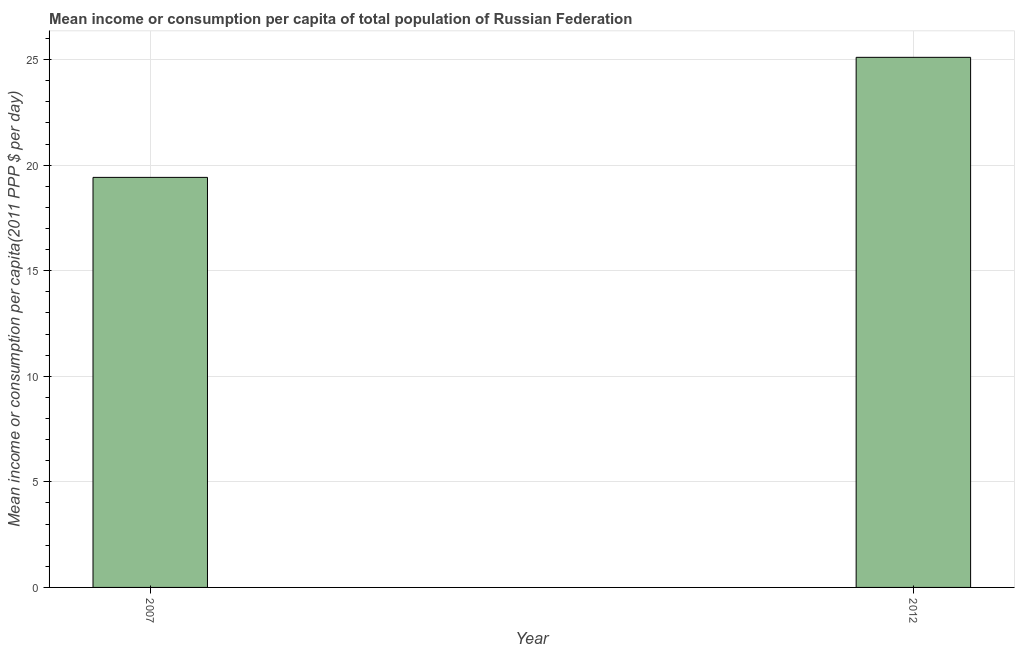What is the title of the graph?
Give a very brief answer. Mean income or consumption per capita of total population of Russian Federation. What is the label or title of the X-axis?
Offer a very short reply. Year. What is the label or title of the Y-axis?
Make the answer very short. Mean income or consumption per capita(2011 PPP $ per day). What is the mean income or consumption in 2007?
Provide a short and direct response. 19.42. Across all years, what is the maximum mean income or consumption?
Give a very brief answer. 25.11. Across all years, what is the minimum mean income or consumption?
Your answer should be compact. 19.42. In which year was the mean income or consumption maximum?
Your answer should be compact. 2012. What is the sum of the mean income or consumption?
Provide a short and direct response. 44.53. What is the difference between the mean income or consumption in 2007 and 2012?
Your response must be concise. -5.69. What is the average mean income or consumption per year?
Offer a terse response. 22.26. What is the median mean income or consumption?
Your answer should be very brief. 22.26. Do a majority of the years between 2007 and 2012 (inclusive) have mean income or consumption greater than 11 $?
Give a very brief answer. Yes. What is the ratio of the mean income or consumption in 2007 to that in 2012?
Give a very brief answer. 0.77. How many bars are there?
Your response must be concise. 2. What is the Mean income or consumption per capita(2011 PPP $ per day) of 2007?
Ensure brevity in your answer.  19.42. What is the Mean income or consumption per capita(2011 PPP $ per day) of 2012?
Your answer should be very brief. 25.11. What is the difference between the Mean income or consumption per capita(2011 PPP $ per day) in 2007 and 2012?
Provide a succinct answer. -5.69. What is the ratio of the Mean income or consumption per capita(2011 PPP $ per day) in 2007 to that in 2012?
Your answer should be compact. 0.77. 